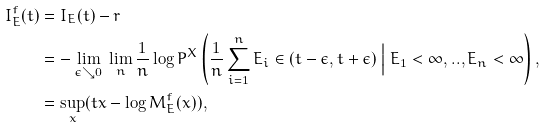Convert formula to latex. <formula><loc_0><loc_0><loc_500><loc_500>I _ { E } ^ { f } ( t ) & = I _ { E } ( t ) - r \\ & = - \lim _ { \epsilon \searrow 0 } \ \lim _ { n } \frac { 1 } { n } \log P ^ { X } \left ( \frac { 1 } { n } \sum _ { i = 1 } ^ { n } E _ { i } \in ( t - \epsilon , t + \epsilon ) \ \Big | \ E _ { 1 } < \infty , . . , E _ { n } < \infty \right ) , \\ & = \sup _ { x } ( t x - \log M _ { E } ^ { f } ( x ) ) ,</formula> 